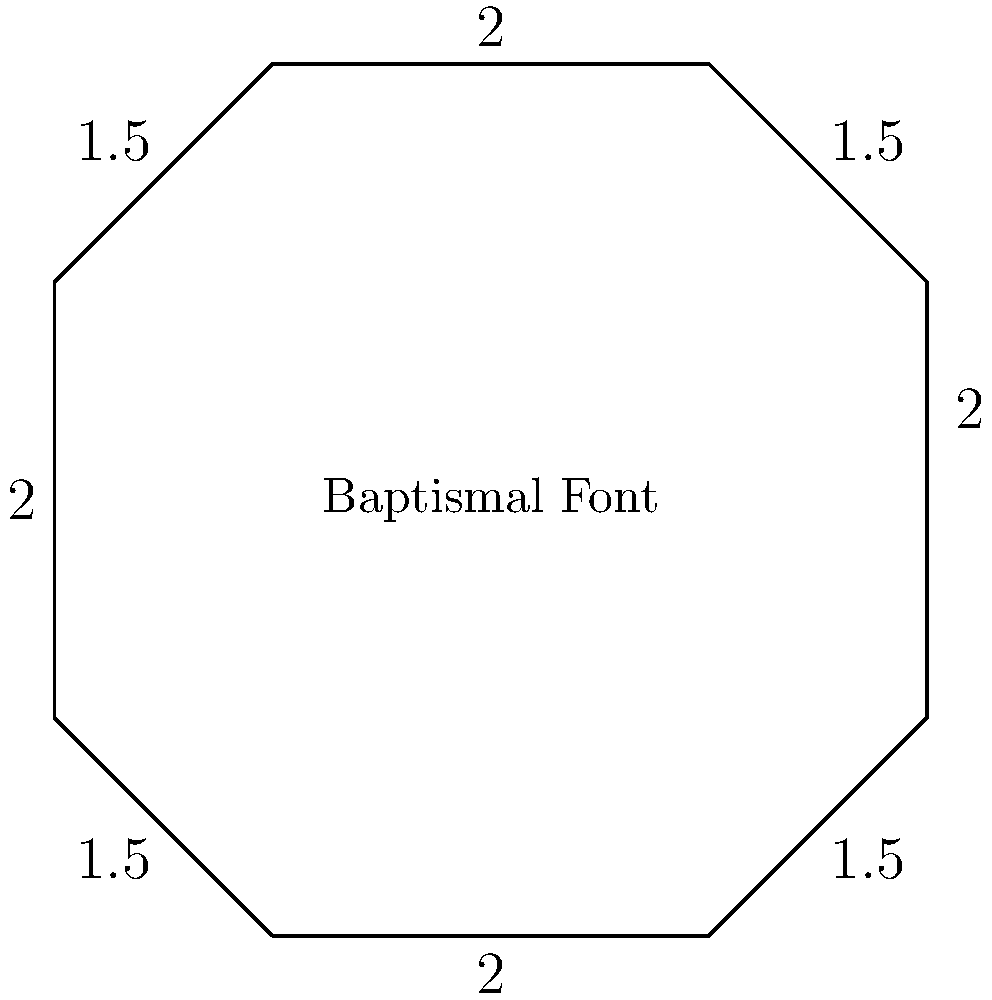The baptismal font in St. Paul's Episcopal Cathedral has an octagonal shape. The lengths of its sides alternate between 2 feet and 1.5 feet, as shown in the diagram. Calculate the perimeter of the baptismal font. To find the perimeter of the octagonal baptismal font, we need to sum up the lengths of all sides. Let's approach this step-by-step:

1) The octagon has 8 sides in total.

2) The sides alternate between 2 feet and 1.5 feet.

3) This means there are:
   - 4 sides of 2 feet each
   - 4 sides of 1.5 feet each

4) Let's calculate:
   - Sum of 2-foot sides: $4 \times 2 = 8$ feet
   - Sum of 1.5-foot sides: $4 \times 1.5 = 6$ feet

5) Total perimeter:
   $$ \text{Perimeter} = 8 \text{ feet} + 6 \text{ feet} = 14 \text{ feet} $$

Therefore, the perimeter of the baptismal font is 14 feet.
Answer: 14 feet 